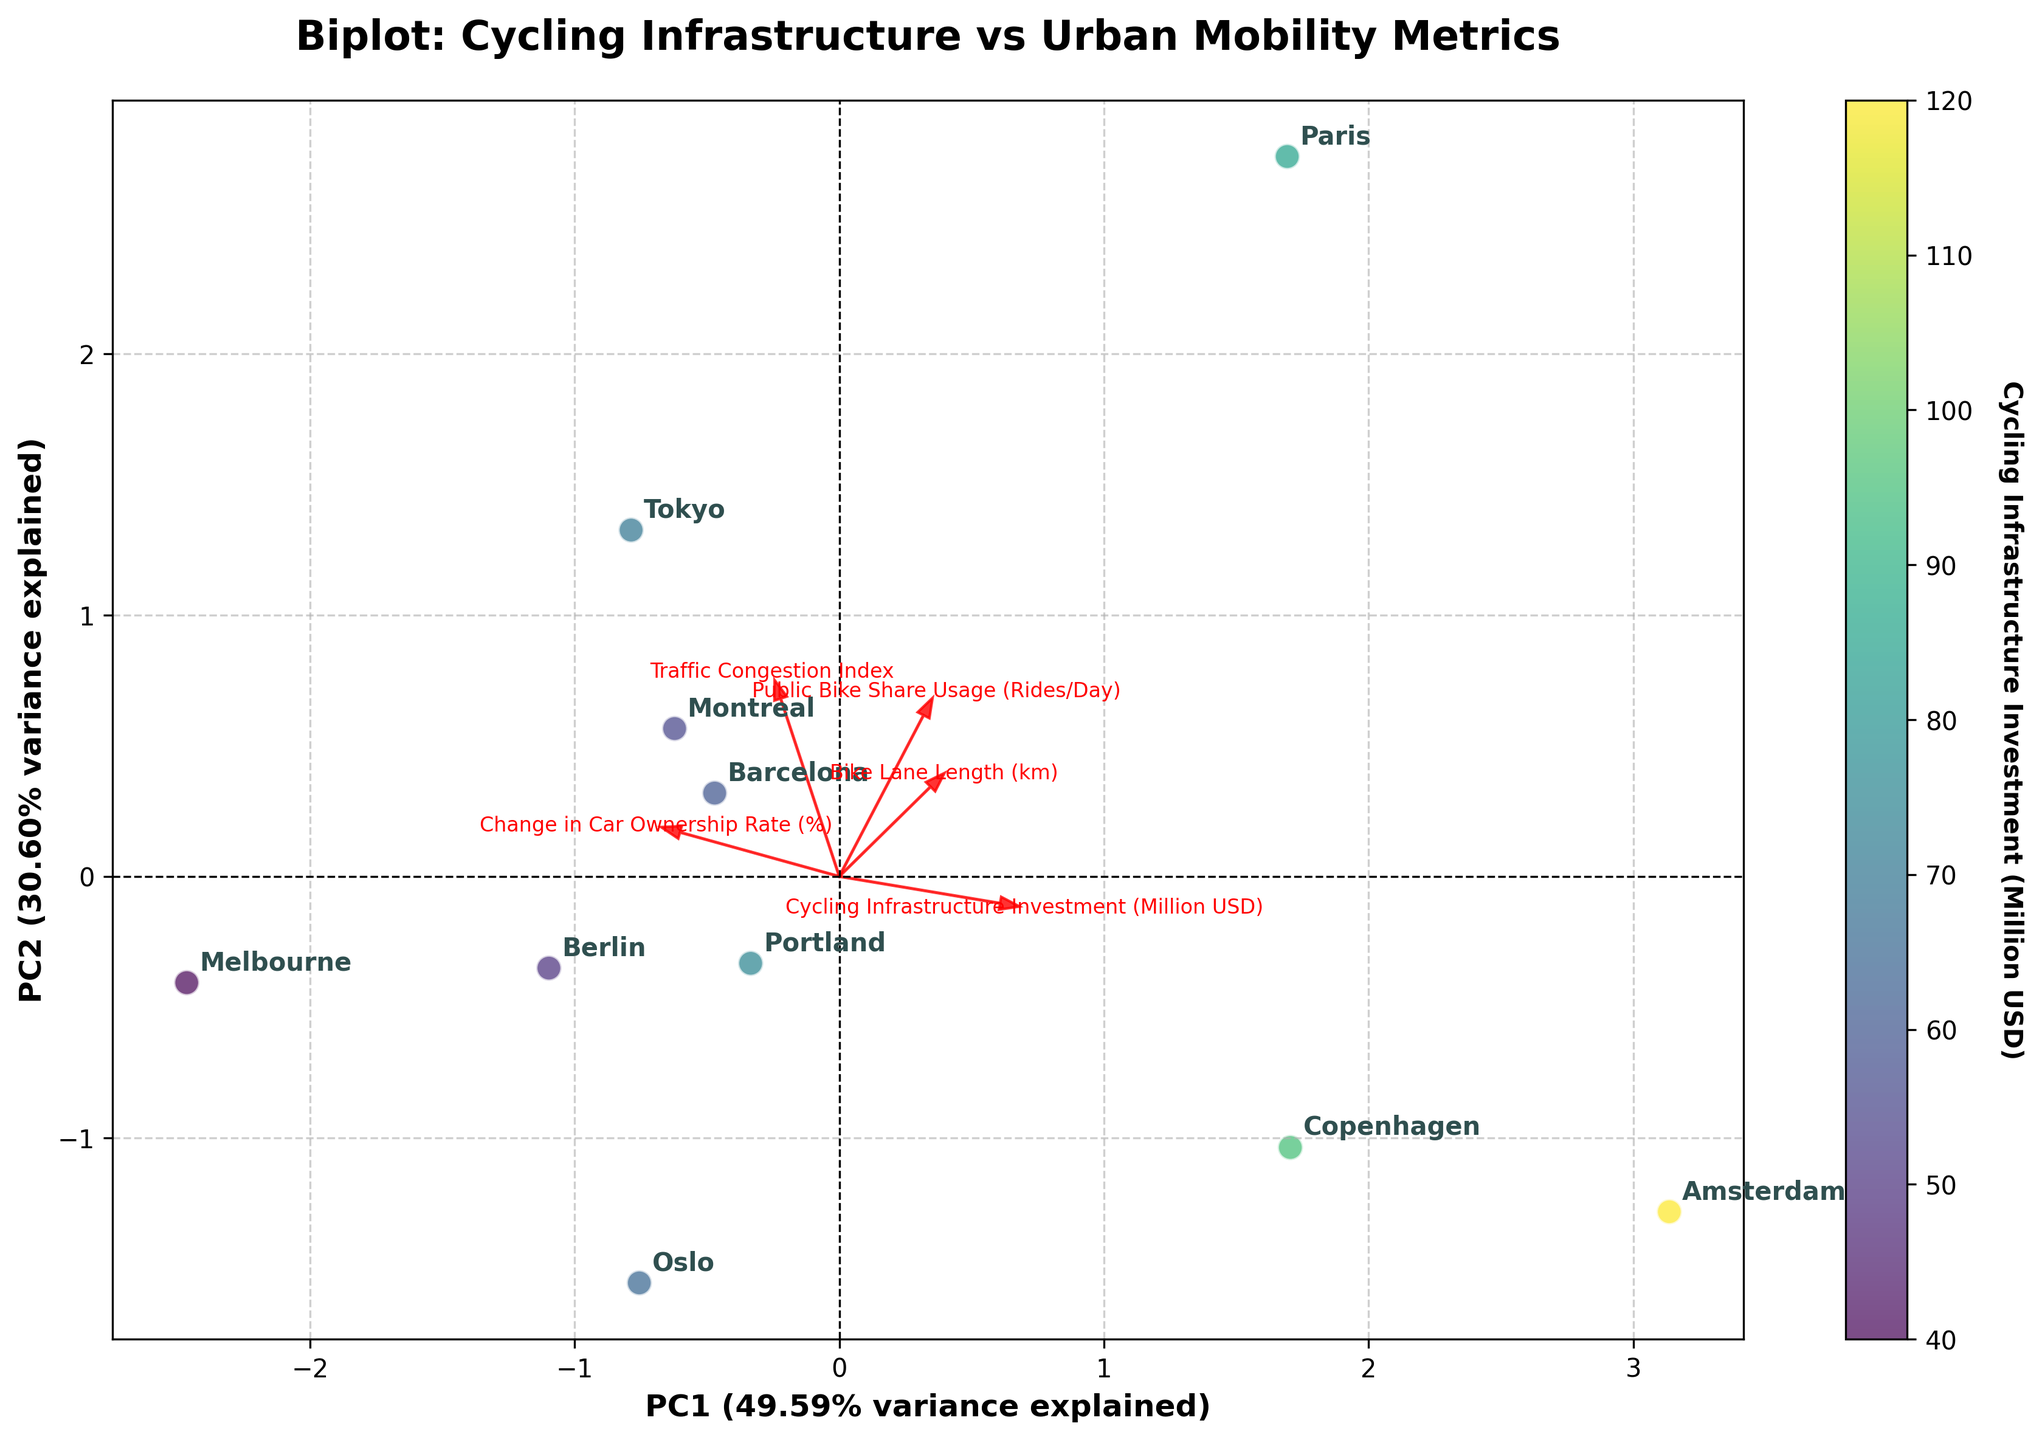What does the title of the figure indicate? The title of the figure, "Biplot: Cycling Infrastructure vs Urban Mobility Metrics," indicates that the figure is a biplot comparing cycling infrastructure investment with various urban mobility metrics.
Answer: Biplot: Cycling Infrastructure vs Urban Mobility Metrics Which city is represented the closest to the origin of the plot? By looking at the position of data points in the biplot, Tokyo is represented closest to the origin.
Answer: Tokyo Which variable has the strongest influence on PC1? The variable with the longest arrow along the PC1 axis has the strongest influence on PC1. "Change in Car Ownership Rate (%)" has the longest arrow along PC1.
Answer: Change in Car Ownership Rate (%) How many cities are labeled in the plot? By counting the labels attached to each data point, there are 10 cities labeled in the plot.
Answer: 10 Which city shows the highest "Cycling Infrastructure Investment" based on color intensity? The city with the highest value depicted using the most intense color in the colorbar, representing the highest investment, is Amsterdam.
Answer: Amsterdam Which two features are positively correlated based on the direction of the arrows in the plot? The arrows for "Cycling Infrastructure Investment (Million USD)" and "Bike Lane Length (km)" point in almost the same direction, indicating a positive correlation.
Answer: Cycling Infrastructure Investment (Million USD) and Bike Lane Length (km) Which city has the highest "Public Bike Share Usage (Rides/Day)" and how can you tell? Paris has the highest "Public Bike Share Usage (Rides/Day)" as indicated by its position further along the direction of this feature vector's arrow.
Answer: Paris What percentage of variance is explained by PC1? The x-axis is labeled "PC1 (xx% variance explained)," indicating the variance explained by PC1. Looking at the axis label, it is approximately 50%.
Answer: 50% Is there a city with both high "Traffic Congestion Index" and significant "Cycling Infrastructure Investment"? If so, name the city. Tokyo is the city positioned high along the "Traffic Congestion Index" arrow and marked with an intense color indicating significant investment in cycling infrastructure.
Answer: Tokyo 